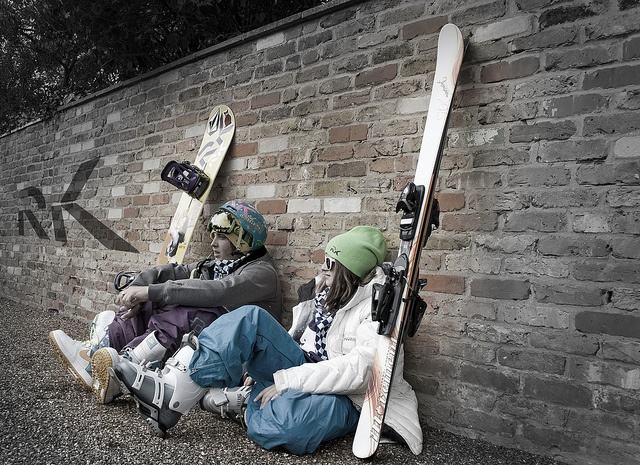Describe the objects in this image and their specific colors. I can see people in black, lightgray, darkgray, and blue tones, people in black, gray, darkgray, and lightgray tones, snowboard in black, white, darkgray, and gray tones, and snowboard in black, ivory, darkgray, and gray tones in this image. 